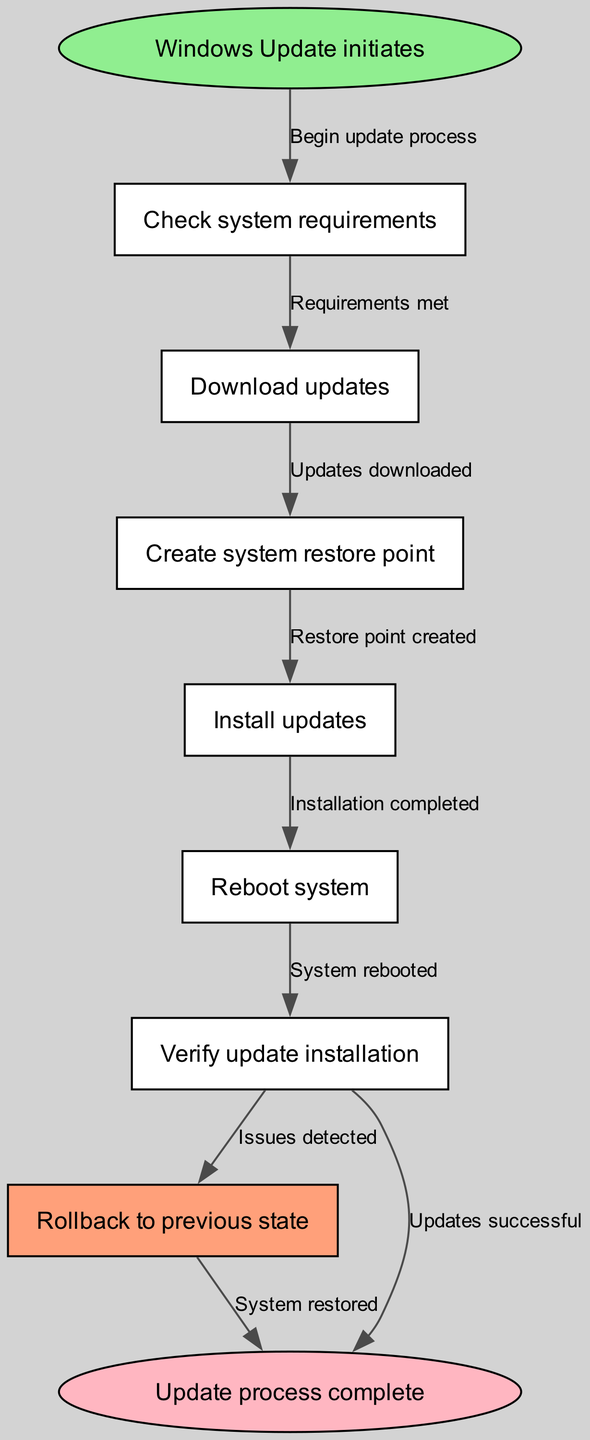What is the first step in the Windows Update process? The first step listed in the diagram is "Windows Update initiates." This can be found at the starting node labeled 'start.'
Answer: Windows Update initiates How many nodes are there in the flowchart? By counting each unique node in the diagram, there are 9 distinct nodes representing various steps in the Windows Update process.
Answer: 9 What happens after creating a system restore point? Following the "Create system restore point," the next step indicated in the flowchart is "Install updates." This connection is shown by the edge going from 'backup' to 'install.'
Answer: Install updates What action occurs if issues are detected during verification? If updates are unsuccessful during the verification step, the flowchart indicates that the process will lead to a "Rollback to previous state," which is found by following the arrow from 'verify' to 'rollback.'
Answer: Rollback to previous state Which step indicates that the update process has reached completion? The final step in the flowchart, indicating that all updates have been successfully completed, is "Update process complete." This is indicated at the ending node labeled 'end.'
Answer: Update process complete What triggers the rollback process? The rollback process is triggered when the "Verify update installation" step detects issues, as shown by the edge from 'verify' leading to 'rollback.' This indicates a negative outcome from the verification.
Answer: Issues detected What is the role of the "Reboot system" in the process? "Reboot system" serves as a necessary transition between the installation of updates and verifying their installation. It can be identified following the "Install updates" node moving to the "Reboot system" node.
Answer: Necessary transition Which node represents a success in the update installation process? The success of the update installation is depicted in the "Updates successful" step that leads directly to the end of the process, connecting from 'verify' to 'end.'
Answer: Updates successful 